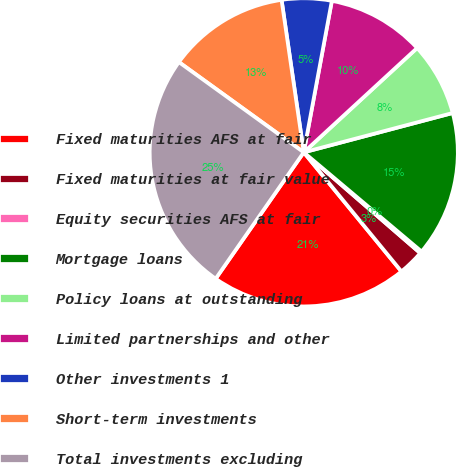<chart> <loc_0><loc_0><loc_500><loc_500><pie_chart><fcel>Fixed maturities AFS at fair<fcel>Fixed maturities at fair value<fcel>Equity securities AFS at fair<fcel>Mortgage loans<fcel>Policy loans at outstanding<fcel>Limited partnerships and other<fcel>Other investments 1<fcel>Short-term investments<fcel>Total investments excluding<nl><fcel>20.62%<fcel>2.72%<fcel>0.21%<fcel>15.25%<fcel>7.73%<fcel>10.24%<fcel>5.22%<fcel>12.74%<fcel>25.27%<nl></chart> 